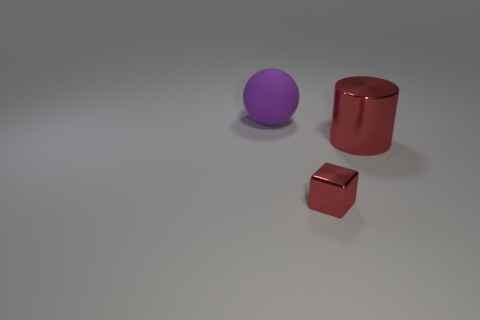Is the material of the red thing to the left of the big red metal cylinder the same as the sphere? Based on the visual properties observed in the image, the red object to the left of the large red cylinder appears to have a different finish and may reflect light differently compared to the sphere, suggesting that they are not made of the same material. 